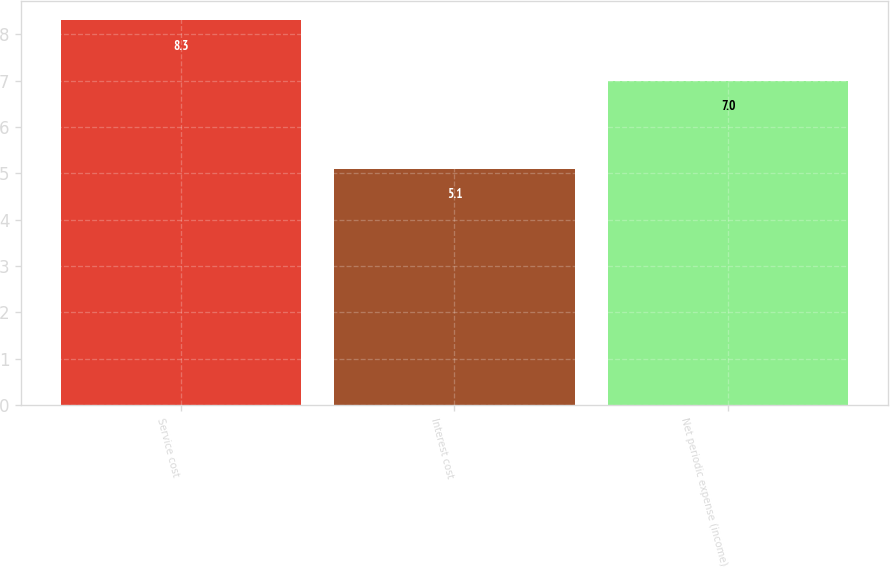<chart> <loc_0><loc_0><loc_500><loc_500><bar_chart><fcel>Service cost<fcel>Interest cost<fcel>Net periodic expense (income)<nl><fcel>8.3<fcel>5.1<fcel>7<nl></chart> 